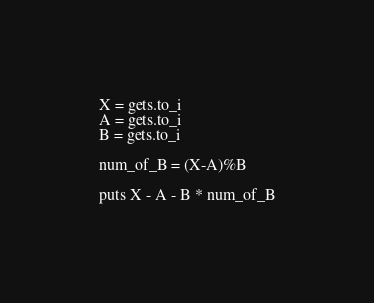<code> <loc_0><loc_0><loc_500><loc_500><_Ruby_>X = gets.to_i
A = gets.to_i
B = gets.to_i

num_of_B = (X-A)%B

puts X - A - B * num_of_B</code> 